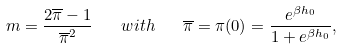<formula> <loc_0><loc_0><loc_500><loc_500>m = \frac { 2 \overline { \pi } - 1 } { \overline { \pi } ^ { 2 } } \quad w i t h \quad \overline { \pi } = \pi ( 0 ) = \frac { e ^ { \beta h _ { 0 } } } { 1 + e ^ { \beta h _ { 0 } } } ,</formula> 